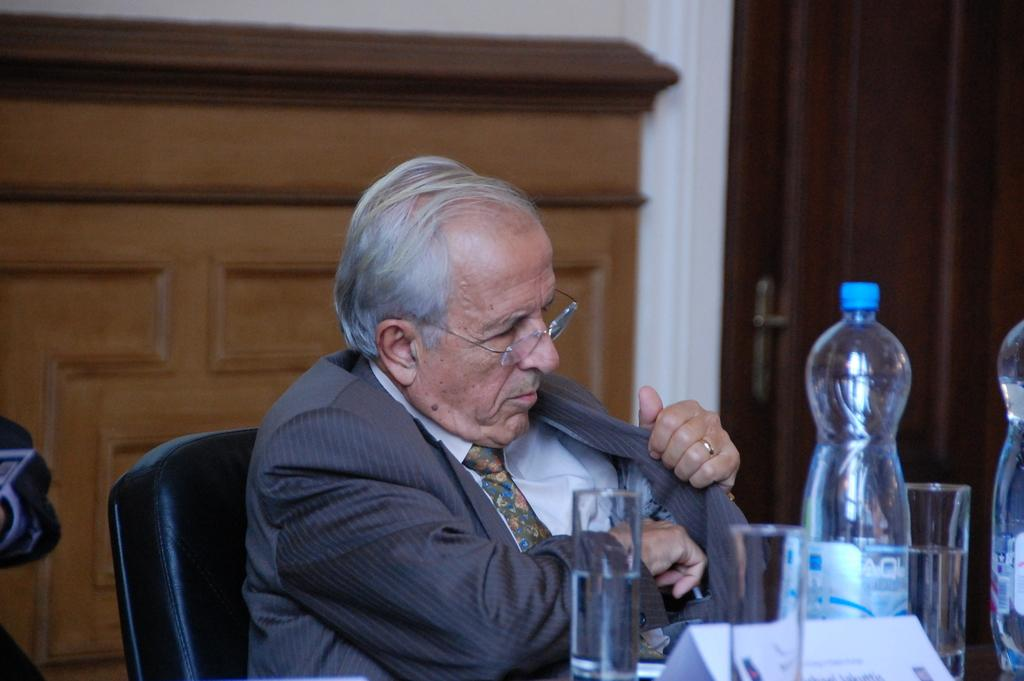What is the man in the image doing? The man is sitting on a chair in the image. What objects are in front of the man? There is a bottle and two glasses in front of the man. What can be seen in the background of the image? There is a cupboard and a wall visible in the background of the image. What is the man learning in the image? There is no indication in the image that the man is learning anything. The image only shows a man sitting on a chair with a bottle and two glasses in front of him. 